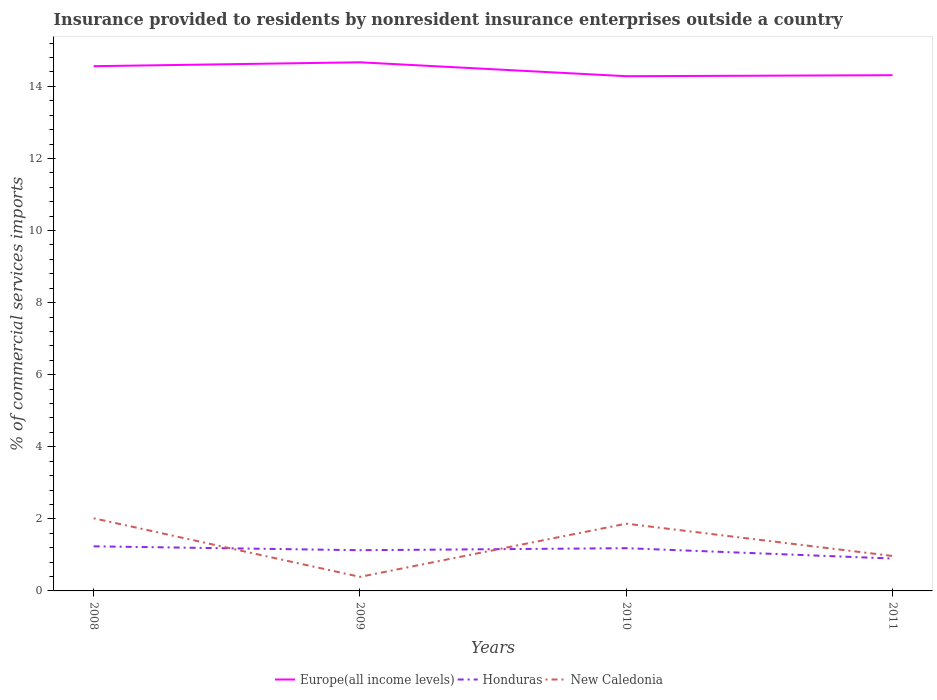Across all years, what is the maximum Insurance provided to residents in Europe(all income levels)?
Your answer should be compact. 14.28. In which year was the Insurance provided to residents in New Caledonia maximum?
Ensure brevity in your answer.  2009. What is the total Insurance provided to residents in Europe(all income levels) in the graph?
Offer a very short reply. -0.11. What is the difference between the highest and the second highest Insurance provided to residents in Europe(all income levels)?
Provide a short and direct response. 0.39. Is the Insurance provided to residents in Europe(all income levels) strictly greater than the Insurance provided to residents in Honduras over the years?
Offer a terse response. No. How many lines are there?
Your answer should be very brief. 3. How many years are there in the graph?
Give a very brief answer. 4. What is the difference between two consecutive major ticks on the Y-axis?
Provide a short and direct response. 2. Are the values on the major ticks of Y-axis written in scientific E-notation?
Offer a very short reply. No. Does the graph contain any zero values?
Your response must be concise. No. Does the graph contain grids?
Your answer should be compact. No. Where does the legend appear in the graph?
Offer a terse response. Bottom center. What is the title of the graph?
Make the answer very short. Insurance provided to residents by nonresident insurance enterprises outside a country. What is the label or title of the Y-axis?
Offer a very short reply. % of commercial services imports. What is the % of commercial services imports of Europe(all income levels) in 2008?
Your answer should be compact. 14.56. What is the % of commercial services imports of Honduras in 2008?
Give a very brief answer. 1.24. What is the % of commercial services imports in New Caledonia in 2008?
Your response must be concise. 2.02. What is the % of commercial services imports in Europe(all income levels) in 2009?
Provide a short and direct response. 14.67. What is the % of commercial services imports in Honduras in 2009?
Make the answer very short. 1.13. What is the % of commercial services imports in New Caledonia in 2009?
Provide a succinct answer. 0.39. What is the % of commercial services imports in Europe(all income levels) in 2010?
Your answer should be compact. 14.28. What is the % of commercial services imports of Honduras in 2010?
Provide a short and direct response. 1.19. What is the % of commercial services imports in New Caledonia in 2010?
Offer a terse response. 1.87. What is the % of commercial services imports of Europe(all income levels) in 2011?
Offer a terse response. 14.31. What is the % of commercial services imports of Honduras in 2011?
Your answer should be very brief. 0.9. What is the % of commercial services imports in New Caledonia in 2011?
Offer a terse response. 0.97. Across all years, what is the maximum % of commercial services imports of Europe(all income levels)?
Your answer should be very brief. 14.67. Across all years, what is the maximum % of commercial services imports in Honduras?
Ensure brevity in your answer.  1.24. Across all years, what is the maximum % of commercial services imports of New Caledonia?
Your answer should be compact. 2.02. Across all years, what is the minimum % of commercial services imports of Europe(all income levels)?
Your answer should be very brief. 14.28. Across all years, what is the minimum % of commercial services imports in Honduras?
Your response must be concise. 0.9. Across all years, what is the minimum % of commercial services imports in New Caledonia?
Offer a terse response. 0.39. What is the total % of commercial services imports in Europe(all income levels) in the graph?
Your response must be concise. 57.82. What is the total % of commercial services imports in Honduras in the graph?
Keep it short and to the point. 4.45. What is the total % of commercial services imports in New Caledonia in the graph?
Provide a short and direct response. 5.24. What is the difference between the % of commercial services imports of Europe(all income levels) in 2008 and that in 2009?
Give a very brief answer. -0.11. What is the difference between the % of commercial services imports in Honduras in 2008 and that in 2009?
Keep it short and to the point. 0.11. What is the difference between the % of commercial services imports of New Caledonia in 2008 and that in 2009?
Provide a succinct answer. 1.63. What is the difference between the % of commercial services imports in Europe(all income levels) in 2008 and that in 2010?
Give a very brief answer. 0.28. What is the difference between the % of commercial services imports in Honduras in 2008 and that in 2010?
Provide a succinct answer. 0.05. What is the difference between the % of commercial services imports in New Caledonia in 2008 and that in 2010?
Your answer should be very brief. 0.15. What is the difference between the % of commercial services imports of Europe(all income levels) in 2008 and that in 2011?
Provide a short and direct response. 0.25. What is the difference between the % of commercial services imports of Honduras in 2008 and that in 2011?
Offer a very short reply. 0.34. What is the difference between the % of commercial services imports of New Caledonia in 2008 and that in 2011?
Offer a very short reply. 1.05. What is the difference between the % of commercial services imports of Europe(all income levels) in 2009 and that in 2010?
Make the answer very short. 0.39. What is the difference between the % of commercial services imports in Honduras in 2009 and that in 2010?
Your answer should be compact. -0.06. What is the difference between the % of commercial services imports in New Caledonia in 2009 and that in 2010?
Offer a very short reply. -1.48. What is the difference between the % of commercial services imports in Europe(all income levels) in 2009 and that in 2011?
Make the answer very short. 0.36. What is the difference between the % of commercial services imports in Honduras in 2009 and that in 2011?
Your answer should be compact. 0.23. What is the difference between the % of commercial services imports of New Caledonia in 2009 and that in 2011?
Give a very brief answer. -0.58. What is the difference between the % of commercial services imports in Europe(all income levels) in 2010 and that in 2011?
Offer a very short reply. -0.03. What is the difference between the % of commercial services imports in Honduras in 2010 and that in 2011?
Provide a short and direct response. 0.29. What is the difference between the % of commercial services imports of New Caledonia in 2010 and that in 2011?
Provide a succinct answer. 0.9. What is the difference between the % of commercial services imports of Europe(all income levels) in 2008 and the % of commercial services imports of Honduras in 2009?
Your answer should be very brief. 13.43. What is the difference between the % of commercial services imports of Europe(all income levels) in 2008 and the % of commercial services imports of New Caledonia in 2009?
Keep it short and to the point. 14.17. What is the difference between the % of commercial services imports of Honduras in 2008 and the % of commercial services imports of New Caledonia in 2009?
Keep it short and to the point. 0.85. What is the difference between the % of commercial services imports of Europe(all income levels) in 2008 and the % of commercial services imports of Honduras in 2010?
Your answer should be compact. 13.37. What is the difference between the % of commercial services imports in Europe(all income levels) in 2008 and the % of commercial services imports in New Caledonia in 2010?
Ensure brevity in your answer.  12.69. What is the difference between the % of commercial services imports of Honduras in 2008 and the % of commercial services imports of New Caledonia in 2010?
Provide a succinct answer. -0.63. What is the difference between the % of commercial services imports in Europe(all income levels) in 2008 and the % of commercial services imports in Honduras in 2011?
Ensure brevity in your answer.  13.66. What is the difference between the % of commercial services imports of Europe(all income levels) in 2008 and the % of commercial services imports of New Caledonia in 2011?
Provide a short and direct response. 13.59. What is the difference between the % of commercial services imports of Honduras in 2008 and the % of commercial services imports of New Caledonia in 2011?
Your answer should be compact. 0.27. What is the difference between the % of commercial services imports of Europe(all income levels) in 2009 and the % of commercial services imports of Honduras in 2010?
Keep it short and to the point. 13.48. What is the difference between the % of commercial services imports in Europe(all income levels) in 2009 and the % of commercial services imports in New Caledonia in 2010?
Your answer should be compact. 12.8. What is the difference between the % of commercial services imports of Honduras in 2009 and the % of commercial services imports of New Caledonia in 2010?
Your answer should be compact. -0.74. What is the difference between the % of commercial services imports of Europe(all income levels) in 2009 and the % of commercial services imports of Honduras in 2011?
Provide a succinct answer. 13.77. What is the difference between the % of commercial services imports in Europe(all income levels) in 2009 and the % of commercial services imports in New Caledonia in 2011?
Provide a short and direct response. 13.7. What is the difference between the % of commercial services imports in Honduras in 2009 and the % of commercial services imports in New Caledonia in 2011?
Ensure brevity in your answer.  0.16. What is the difference between the % of commercial services imports of Europe(all income levels) in 2010 and the % of commercial services imports of Honduras in 2011?
Make the answer very short. 13.38. What is the difference between the % of commercial services imports in Europe(all income levels) in 2010 and the % of commercial services imports in New Caledonia in 2011?
Make the answer very short. 13.31. What is the difference between the % of commercial services imports of Honduras in 2010 and the % of commercial services imports of New Caledonia in 2011?
Your answer should be very brief. 0.22. What is the average % of commercial services imports of Europe(all income levels) per year?
Make the answer very short. 14.45. What is the average % of commercial services imports of Honduras per year?
Your answer should be compact. 1.11. What is the average % of commercial services imports in New Caledonia per year?
Ensure brevity in your answer.  1.31. In the year 2008, what is the difference between the % of commercial services imports of Europe(all income levels) and % of commercial services imports of Honduras?
Ensure brevity in your answer.  13.32. In the year 2008, what is the difference between the % of commercial services imports of Europe(all income levels) and % of commercial services imports of New Caledonia?
Your response must be concise. 12.54. In the year 2008, what is the difference between the % of commercial services imports of Honduras and % of commercial services imports of New Caledonia?
Your response must be concise. -0.78. In the year 2009, what is the difference between the % of commercial services imports in Europe(all income levels) and % of commercial services imports in Honduras?
Your answer should be compact. 13.54. In the year 2009, what is the difference between the % of commercial services imports of Europe(all income levels) and % of commercial services imports of New Caledonia?
Make the answer very short. 14.28. In the year 2009, what is the difference between the % of commercial services imports in Honduras and % of commercial services imports in New Caledonia?
Keep it short and to the point. 0.74. In the year 2010, what is the difference between the % of commercial services imports in Europe(all income levels) and % of commercial services imports in Honduras?
Make the answer very short. 13.1. In the year 2010, what is the difference between the % of commercial services imports of Europe(all income levels) and % of commercial services imports of New Caledonia?
Ensure brevity in your answer.  12.42. In the year 2010, what is the difference between the % of commercial services imports in Honduras and % of commercial services imports in New Caledonia?
Offer a very short reply. -0.68. In the year 2011, what is the difference between the % of commercial services imports of Europe(all income levels) and % of commercial services imports of Honduras?
Your response must be concise. 13.41. In the year 2011, what is the difference between the % of commercial services imports of Europe(all income levels) and % of commercial services imports of New Caledonia?
Keep it short and to the point. 13.34. In the year 2011, what is the difference between the % of commercial services imports of Honduras and % of commercial services imports of New Caledonia?
Make the answer very short. -0.07. What is the ratio of the % of commercial services imports of Honduras in 2008 to that in 2009?
Your response must be concise. 1.1. What is the ratio of the % of commercial services imports of New Caledonia in 2008 to that in 2009?
Provide a succinct answer. 5.17. What is the ratio of the % of commercial services imports of Europe(all income levels) in 2008 to that in 2010?
Your answer should be compact. 1.02. What is the ratio of the % of commercial services imports in Honduras in 2008 to that in 2010?
Offer a very short reply. 1.04. What is the ratio of the % of commercial services imports of New Caledonia in 2008 to that in 2010?
Your response must be concise. 1.08. What is the ratio of the % of commercial services imports in Europe(all income levels) in 2008 to that in 2011?
Your answer should be very brief. 1.02. What is the ratio of the % of commercial services imports of Honduras in 2008 to that in 2011?
Give a very brief answer. 1.38. What is the ratio of the % of commercial services imports of New Caledonia in 2008 to that in 2011?
Give a very brief answer. 2.08. What is the ratio of the % of commercial services imports in Europe(all income levels) in 2009 to that in 2010?
Offer a very short reply. 1.03. What is the ratio of the % of commercial services imports of Honduras in 2009 to that in 2010?
Provide a short and direct response. 0.95. What is the ratio of the % of commercial services imports in New Caledonia in 2009 to that in 2010?
Offer a very short reply. 0.21. What is the ratio of the % of commercial services imports of Europe(all income levels) in 2009 to that in 2011?
Your answer should be compact. 1.02. What is the ratio of the % of commercial services imports of Honduras in 2009 to that in 2011?
Provide a succinct answer. 1.26. What is the ratio of the % of commercial services imports of New Caledonia in 2009 to that in 2011?
Ensure brevity in your answer.  0.4. What is the ratio of the % of commercial services imports of Honduras in 2010 to that in 2011?
Offer a very short reply. 1.32. What is the ratio of the % of commercial services imports of New Caledonia in 2010 to that in 2011?
Your response must be concise. 1.92. What is the difference between the highest and the second highest % of commercial services imports in Europe(all income levels)?
Give a very brief answer. 0.11. What is the difference between the highest and the second highest % of commercial services imports in Honduras?
Ensure brevity in your answer.  0.05. What is the difference between the highest and the second highest % of commercial services imports in New Caledonia?
Make the answer very short. 0.15. What is the difference between the highest and the lowest % of commercial services imports in Europe(all income levels)?
Make the answer very short. 0.39. What is the difference between the highest and the lowest % of commercial services imports in Honduras?
Make the answer very short. 0.34. What is the difference between the highest and the lowest % of commercial services imports of New Caledonia?
Your response must be concise. 1.63. 